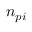Convert formula to latex. <formula><loc_0><loc_0><loc_500><loc_500>n _ { p i }</formula> 